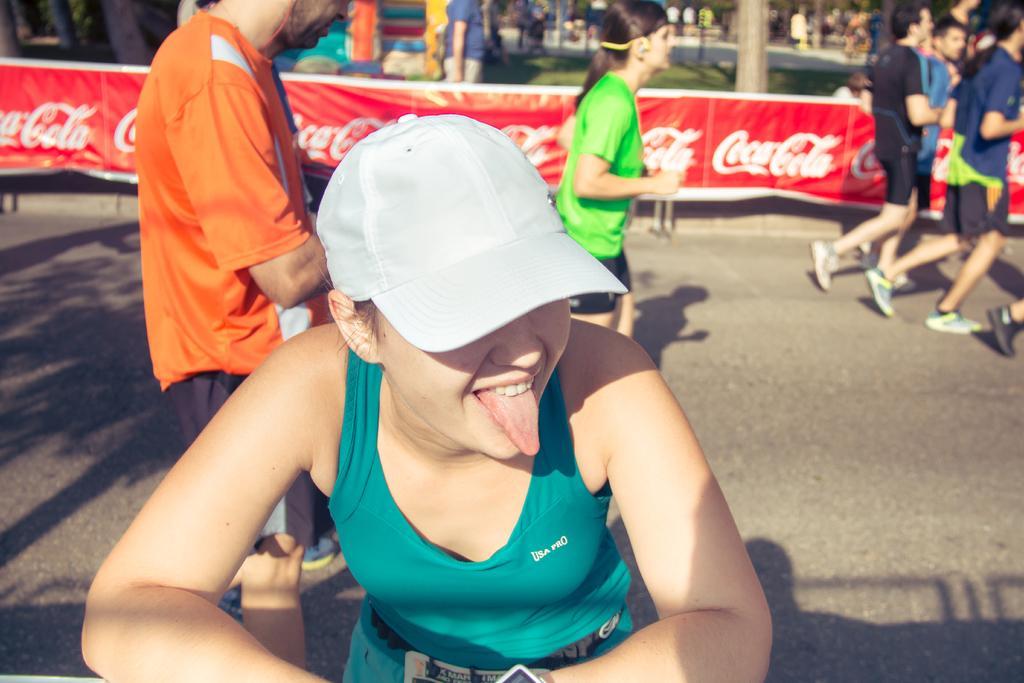How would you summarize this image in a sentence or two? In this image I can see few persons, some are standing and some are running. In front the person is wearing green color dress and white color cap. Background I can see a red color banner and I can also see few multicolor objects and trees in green color. 